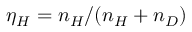<formula> <loc_0><loc_0><loc_500><loc_500>\eta _ { H } = n _ { H } / ( n _ { H } + n _ { D } )</formula> 